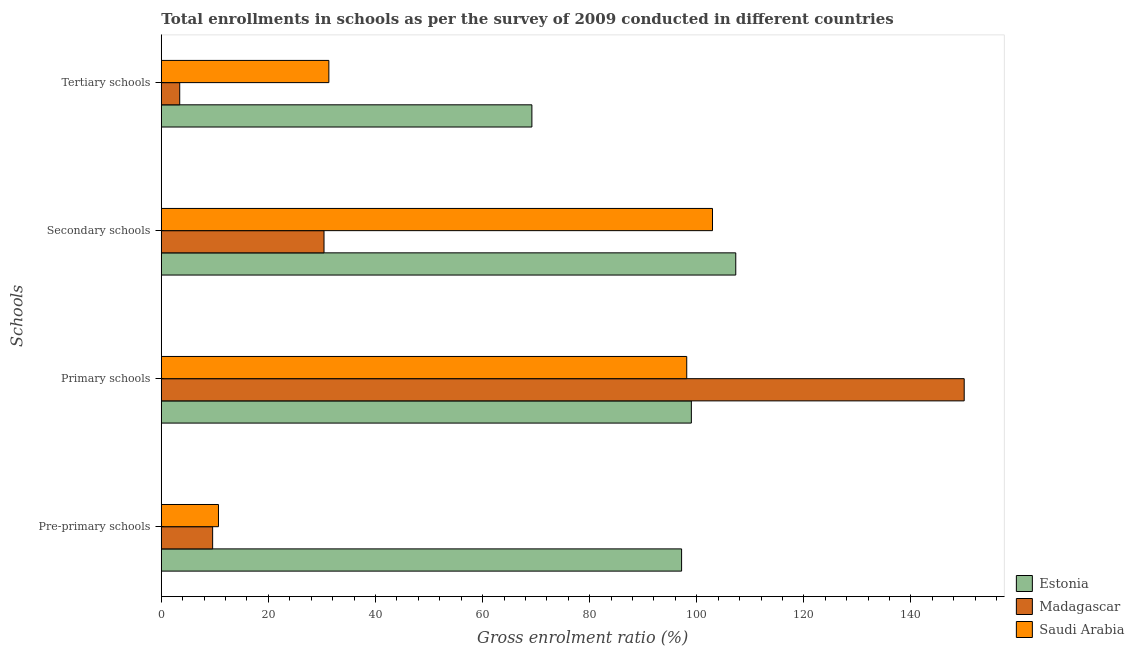How many different coloured bars are there?
Provide a succinct answer. 3. How many bars are there on the 1st tick from the bottom?
Make the answer very short. 3. What is the label of the 1st group of bars from the top?
Make the answer very short. Tertiary schools. What is the gross enrolment ratio in pre-primary schools in Saudi Arabia?
Keep it short and to the point. 10.67. Across all countries, what is the maximum gross enrolment ratio in secondary schools?
Provide a succinct answer. 107.29. Across all countries, what is the minimum gross enrolment ratio in pre-primary schools?
Give a very brief answer. 9.59. In which country was the gross enrolment ratio in tertiary schools maximum?
Keep it short and to the point. Estonia. In which country was the gross enrolment ratio in tertiary schools minimum?
Offer a terse response. Madagascar. What is the total gross enrolment ratio in pre-primary schools in the graph?
Ensure brevity in your answer.  117.43. What is the difference between the gross enrolment ratio in pre-primary schools in Saudi Arabia and that in Madagascar?
Offer a very short reply. 1.09. What is the difference between the gross enrolment ratio in tertiary schools in Estonia and the gross enrolment ratio in primary schools in Saudi Arabia?
Offer a very short reply. -28.92. What is the average gross enrolment ratio in tertiary schools per country?
Offer a very short reply. 34.65. What is the difference between the gross enrolment ratio in tertiary schools and gross enrolment ratio in primary schools in Saudi Arabia?
Your response must be concise. -66.84. What is the ratio of the gross enrolment ratio in primary schools in Madagascar to that in Estonia?
Offer a terse response. 1.51. Is the difference between the gross enrolment ratio in tertiary schools in Saudi Arabia and Estonia greater than the difference between the gross enrolment ratio in secondary schools in Saudi Arabia and Estonia?
Offer a very short reply. No. What is the difference between the highest and the second highest gross enrolment ratio in secondary schools?
Provide a short and direct response. 4.34. What is the difference between the highest and the lowest gross enrolment ratio in tertiary schools?
Keep it short and to the point. 65.77. Is the sum of the gross enrolment ratio in primary schools in Saudi Arabia and Madagascar greater than the maximum gross enrolment ratio in pre-primary schools across all countries?
Make the answer very short. Yes. What does the 1st bar from the top in Pre-primary schools represents?
Provide a succinct answer. Saudi Arabia. What does the 2nd bar from the bottom in Pre-primary schools represents?
Provide a short and direct response. Madagascar. How many bars are there?
Make the answer very short. 12. Are all the bars in the graph horizontal?
Your answer should be compact. Yes. How many countries are there in the graph?
Keep it short and to the point. 3. Are the values on the major ticks of X-axis written in scientific E-notation?
Your response must be concise. No. Does the graph contain any zero values?
Provide a short and direct response. No. Does the graph contain grids?
Keep it short and to the point. No. Where does the legend appear in the graph?
Keep it short and to the point. Bottom right. How many legend labels are there?
Your response must be concise. 3. What is the title of the graph?
Provide a succinct answer. Total enrollments in schools as per the survey of 2009 conducted in different countries. Does "Rwanda" appear as one of the legend labels in the graph?
Ensure brevity in your answer.  No. What is the label or title of the Y-axis?
Your answer should be very brief. Schools. What is the Gross enrolment ratio (%) in Estonia in Pre-primary schools?
Your answer should be very brief. 97.17. What is the Gross enrolment ratio (%) of Madagascar in Pre-primary schools?
Give a very brief answer. 9.59. What is the Gross enrolment ratio (%) of Saudi Arabia in Pre-primary schools?
Your response must be concise. 10.67. What is the Gross enrolment ratio (%) of Estonia in Primary schools?
Your response must be concise. 98.99. What is the Gross enrolment ratio (%) of Madagascar in Primary schools?
Offer a very short reply. 149.95. What is the Gross enrolment ratio (%) in Saudi Arabia in Primary schools?
Ensure brevity in your answer.  98.13. What is the Gross enrolment ratio (%) in Estonia in Secondary schools?
Provide a short and direct response. 107.29. What is the Gross enrolment ratio (%) in Madagascar in Secondary schools?
Your answer should be very brief. 30.39. What is the Gross enrolment ratio (%) in Saudi Arabia in Secondary schools?
Make the answer very short. 102.94. What is the Gross enrolment ratio (%) of Estonia in Tertiary schools?
Keep it short and to the point. 69.21. What is the Gross enrolment ratio (%) of Madagascar in Tertiary schools?
Give a very brief answer. 3.44. What is the Gross enrolment ratio (%) in Saudi Arabia in Tertiary schools?
Make the answer very short. 31.29. Across all Schools, what is the maximum Gross enrolment ratio (%) in Estonia?
Your response must be concise. 107.29. Across all Schools, what is the maximum Gross enrolment ratio (%) of Madagascar?
Your answer should be very brief. 149.95. Across all Schools, what is the maximum Gross enrolment ratio (%) in Saudi Arabia?
Keep it short and to the point. 102.94. Across all Schools, what is the minimum Gross enrolment ratio (%) in Estonia?
Offer a very short reply. 69.21. Across all Schools, what is the minimum Gross enrolment ratio (%) in Madagascar?
Your answer should be compact. 3.44. Across all Schools, what is the minimum Gross enrolment ratio (%) in Saudi Arabia?
Offer a terse response. 10.67. What is the total Gross enrolment ratio (%) of Estonia in the graph?
Ensure brevity in your answer.  372.66. What is the total Gross enrolment ratio (%) of Madagascar in the graph?
Make the answer very short. 193.36. What is the total Gross enrolment ratio (%) of Saudi Arabia in the graph?
Make the answer very short. 243.04. What is the difference between the Gross enrolment ratio (%) of Estonia in Pre-primary schools and that in Primary schools?
Provide a short and direct response. -1.82. What is the difference between the Gross enrolment ratio (%) in Madagascar in Pre-primary schools and that in Primary schools?
Keep it short and to the point. -140.37. What is the difference between the Gross enrolment ratio (%) in Saudi Arabia in Pre-primary schools and that in Primary schools?
Offer a very short reply. -87.46. What is the difference between the Gross enrolment ratio (%) of Estonia in Pre-primary schools and that in Secondary schools?
Offer a terse response. -10.12. What is the difference between the Gross enrolment ratio (%) of Madagascar in Pre-primary schools and that in Secondary schools?
Offer a very short reply. -20.8. What is the difference between the Gross enrolment ratio (%) in Saudi Arabia in Pre-primary schools and that in Secondary schools?
Make the answer very short. -92.27. What is the difference between the Gross enrolment ratio (%) of Estonia in Pre-primary schools and that in Tertiary schools?
Your response must be concise. 27.96. What is the difference between the Gross enrolment ratio (%) in Madagascar in Pre-primary schools and that in Tertiary schools?
Keep it short and to the point. 6.15. What is the difference between the Gross enrolment ratio (%) of Saudi Arabia in Pre-primary schools and that in Tertiary schools?
Your answer should be very brief. -20.62. What is the difference between the Gross enrolment ratio (%) of Estonia in Primary schools and that in Secondary schools?
Your answer should be compact. -8.29. What is the difference between the Gross enrolment ratio (%) of Madagascar in Primary schools and that in Secondary schools?
Make the answer very short. 119.57. What is the difference between the Gross enrolment ratio (%) of Saudi Arabia in Primary schools and that in Secondary schools?
Your response must be concise. -4.81. What is the difference between the Gross enrolment ratio (%) of Estonia in Primary schools and that in Tertiary schools?
Make the answer very short. 29.78. What is the difference between the Gross enrolment ratio (%) in Madagascar in Primary schools and that in Tertiary schools?
Your response must be concise. 146.51. What is the difference between the Gross enrolment ratio (%) of Saudi Arabia in Primary schools and that in Tertiary schools?
Provide a short and direct response. 66.84. What is the difference between the Gross enrolment ratio (%) in Estonia in Secondary schools and that in Tertiary schools?
Your response must be concise. 38.08. What is the difference between the Gross enrolment ratio (%) in Madagascar in Secondary schools and that in Tertiary schools?
Make the answer very short. 26.95. What is the difference between the Gross enrolment ratio (%) in Saudi Arabia in Secondary schools and that in Tertiary schools?
Ensure brevity in your answer.  71.65. What is the difference between the Gross enrolment ratio (%) of Estonia in Pre-primary schools and the Gross enrolment ratio (%) of Madagascar in Primary schools?
Keep it short and to the point. -52.78. What is the difference between the Gross enrolment ratio (%) of Estonia in Pre-primary schools and the Gross enrolment ratio (%) of Saudi Arabia in Primary schools?
Give a very brief answer. -0.96. What is the difference between the Gross enrolment ratio (%) of Madagascar in Pre-primary schools and the Gross enrolment ratio (%) of Saudi Arabia in Primary schools?
Your answer should be compact. -88.54. What is the difference between the Gross enrolment ratio (%) of Estonia in Pre-primary schools and the Gross enrolment ratio (%) of Madagascar in Secondary schools?
Your answer should be very brief. 66.78. What is the difference between the Gross enrolment ratio (%) of Estonia in Pre-primary schools and the Gross enrolment ratio (%) of Saudi Arabia in Secondary schools?
Your response must be concise. -5.77. What is the difference between the Gross enrolment ratio (%) in Madagascar in Pre-primary schools and the Gross enrolment ratio (%) in Saudi Arabia in Secondary schools?
Keep it short and to the point. -93.36. What is the difference between the Gross enrolment ratio (%) of Estonia in Pre-primary schools and the Gross enrolment ratio (%) of Madagascar in Tertiary schools?
Your response must be concise. 93.73. What is the difference between the Gross enrolment ratio (%) in Estonia in Pre-primary schools and the Gross enrolment ratio (%) in Saudi Arabia in Tertiary schools?
Provide a succinct answer. 65.88. What is the difference between the Gross enrolment ratio (%) of Madagascar in Pre-primary schools and the Gross enrolment ratio (%) of Saudi Arabia in Tertiary schools?
Make the answer very short. -21.71. What is the difference between the Gross enrolment ratio (%) in Estonia in Primary schools and the Gross enrolment ratio (%) in Madagascar in Secondary schools?
Your answer should be very brief. 68.61. What is the difference between the Gross enrolment ratio (%) of Estonia in Primary schools and the Gross enrolment ratio (%) of Saudi Arabia in Secondary schools?
Offer a terse response. -3.95. What is the difference between the Gross enrolment ratio (%) of Madagascar in Primary schools and the Gross enrolment ratio (%) of Saudi Arabia in Secondary schools?
Ensure brevity in your answer.  47.01. What is the difference between the Gross enrolment ratio (%) of Estonia in Primary schools and the Gross enrolment ratio (%) of Madagascar in Tertiary schools?
Your answer should be very brief. 95.55. What is the difference between the Gross enrolment ratio (%) of Estonia in Primary schools and the Gross enrolment ratio (%) of Saudi Arabia in Tertiary schools?
Your answer should be compact. 67.7. What is the difference between the Gross enrolment ratio (%) of Madagascar in Primary schools and the Gross enrolment ratio (%) of Saudi Arabia in Tertiary schools?
Provide a succinct answer. 118.66. What is the difference between the Gross enrolment ratio (%) of Estonia in Secondary schools and the Gross enrolment ratio (%) of Madagascar in Tertiary schools?
Ensure brevity in your answer.  103.85. What is the difference between the Gross enrolment ratio (%) of Estonia in Secondary schools and the Gross enrolment ratio (%) of Saudi Arabia in Tertiary schools?
Your answer should be compact. 75.99. What is the difference between the Gross enrolment ratio (%) of Madagascar in Secondary schools and the Gross enrolment ratio (%) of Saudi Arabia in Tertiary schools?
Provide a short and direct response. -0.91. What is the average Gross enrolment ratio (%) of Estonia per Schools?
Offer a very short reply. 93.16. What is the average Gross enrolment ratio (%) of Madagascar per Schools?
Give a very brief answer. 48.34. What is the average Gross enrolment ratio (%) of Saudi Arabia per Schools?
Keep it short and to the point. 60.76. What is the difference between the Gross enrolment ratio (%) of Estonia and Gross enrolment ratio (%) of Madagascar in Pre-primary schools?
Provide a short and direct response. 87.58. What is the difference between the Gross enrolment ratio (%) in Estonia and Gross enrolment ratio (%) in Saudi Arabia in Pre-primary schools?
Your answer should be compact. 86.5. What is the difference between the Gross enrolment ratio (%) of Madagascar and Gross enrolment ratio (%) of Saudi Arabia in Pre-primary schools?
Provide a short and direct response. -1.09. What is the difference between the Gross enrolment ratio (%) of Estonia and Gross enrolment ratio (%) of Madagascar in Primary schools?
Offer a very short reply. -50.96. What is the difference between the Gross enrolment ratio (%) in Estonia and Gross enrolment ratio (%) in Saudi Arabia in Primary schools?
Offer a terse response. 0.86. What is the difference between the Gross enrolment ratio (%) of Madagascar and Gross enrolment ratio (%) of Saudi Arabia in Primary schools?
Ensure brevity in your answer.  51.82. What is the difference between the Gross enrolment ratio (%) of Estonia and Gross enrolment ratio (%) of Madagascar in Secondary schools?
Make the answer very short. 76.9. What is the difference between the Gross enrolment ratio (%) of Estonia and Gross enrolment ratio (%) of Saudi Arabia in Secondary schools?
Offer a very short reply. 4.34. What is the difference between the Gross enrolment ratio (%) in Madagascar and Gross enrolment ratio (%) in Saudi Arabia in Secondary schools?
Keep it short and to the point. -72.56. What is the difference between the Gross enrolment ratio (%) of Estonia and Gross enrolment ratio (%) of Madagascar in Tertiary schools?
Your answer should be very brief. 65.77. What is the difference between the Gross enrolment ratio (%) in Estonia and Gross enrolment ratio (%) in Saudi Arabia in Tertiary schools?
Your answer should be compact. 37.92. What is the difference between the Gross enrolment ratio (%) of Madagascar and Gross enrolment ratio (%) of Saudi Arabia in Tertiary schools?
Offer a terse response. -27.85. What is the ratio of the Gross enrolment ratio (%) in Estonia in Pre-primary schools to that in Primary schools?
Make the answer very short. 0.98. What is the ratio of the Gross enrolment ratio (%) in Madagascar in Pre-primary schools to that in Primary schools?
Provide a succinct answer. 0.06. What is the ratio of the Gross enrolment ratio (%) in Saudi Arabia in Pre-primary schools to that in Primary schools?
Make the answer very short. 0.11. What is the ratio of the Gross enrolment ratio (%) of Estonia in Pre-primary schools to that in Secondary schools?
Provide a short and direct response. 0.91. What is the ratio of the Gross enrolment ratio (%) of Madagascar in Pre-primary schools to that in Secondary schools?
Your answer should be very brief. 0.32. What is the ratio of the Gross enrolment ratio (%) in Saudi Arabia in Pre-primary schools to that in Secondary schools?
Give a very brief answer. 0.1. What is the ratio of the Gross enrolment ratio (%) in Estonia in Pre-primary schools to that in Tertiary schools?
Provide a short and direct response. 1.4. What is the ratio of the Gross enrolment ratio (%) of Madagascar in Pre-primary schools to that in Tertiary schools?
Offer a terse response. 2.79. What is the ratio of the Gross enrolment ratio (%) of Saudi Arabia in Pre-primary schools to that in Tertiary schools?
Your answer should be very brief. 0.34. What is the ratio of the Gross enrolment ratio (%) in Estonia in Primary schools to that in Secondary schools?
Keep it short and to the point. 0.92. What is the ratio of the Gross enrolment ratio (%) of Madagascar in Primary schools to that in Secondary schools?
Your answer should be very brief. 4.93. What is the ratio of the Gross enrolment ratio (%) in Saudi Arabia in Primary schools to that in Secondary schools?
Give a very brief answer. 0.95. What is the ratio of the Gross enrolment ratio (%) in Estonia in Primary schools to that in Tertiary schools?
Give a very brief answer. 1.43. What is the ratio of the Gross enrolment ratio (%) of Madagascar in Primary schools to that in Tertiary schools?
Your answer should be compact. 43.61. What is the ratio of the Gross enrolment ratio (%) of Saudi Arabia in Primary schools to that in Tertiary schools?
Ensure brevity in your answer.  3.14. What is the ratio of the Gross enrolment ratio (%) of Estonia in Secondary schools to that in Tertiary schools?
Provide a short and direct response. 1.55. What is the ratio of the Gross enrolment ratio (%) of Madagascar in Secondary schools to that in Tertiary schools?
Ensure brevity in your answer.  8.84. What is the ratio of the Gross enrolment ratio (%) of Saudi Arabia in Secondary schools to that in Tertiary schools?
Offer a very short reply. 3.29. What is the difference between the highest and the second highest Gross enrolment ratio (%) in Estonia?
Offer a terse response. 8.29. What is the difference between the highest and the second highest Gross enrolment ratio (%) in Madagascar?
Provide a short and direct response. 119.57. What is the difference between the highest and the second highest Gross enrolment ratio (%) in Saudi Arabia?
Offer a very short reply. 4.81. What is the difference between the highest and the lowest Gross enrolment ratio (%) in Estonia?
Make the answer very short. 38.08. What is the difference between the highest and the lowest Gross enrolment ratio (%) in Madagascar?
Offer a terse response. 146.51. What is the difference between the highest and the lowest Gross enrolment ratio (%) of Saudi Arabia?
Provide a succinct answer. 92.27. 